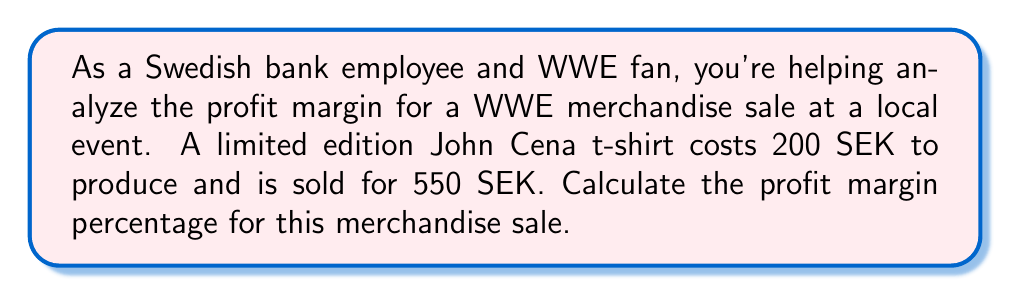Can you solve this math problem? To calculate the profit margin percentage, we need to follow these steps:

1. Calculate the profit:
   Profit = Selling Price - Cost Price
   $$ \text{Profit} = 550 \text{ SEK} - 200 \text{ SEK} = 350 \text{ SEK} $$

2. Calculate the profit margin:
   Profit Margin = Profit ÷ Selling Price
   $$ \text{Profit Margin} = \frac{350 \text{ SEK}}{550 \text{ SEK}} = 0.6363636364 $$

3. Convert the profit margin to a percentage:
   Profit Margin Percentage = Profit Margin × 100%
   $$ \text{Profit Margin Percentage} = 0.6363636364 \times 100\% = 63.64\% $$

Therefore, the profit margin percentage for the John Cena t-shirt sale is approximately 63.64%.
Answer: The profit margin percentage for the WWE merchandise sale is 63.64%. 